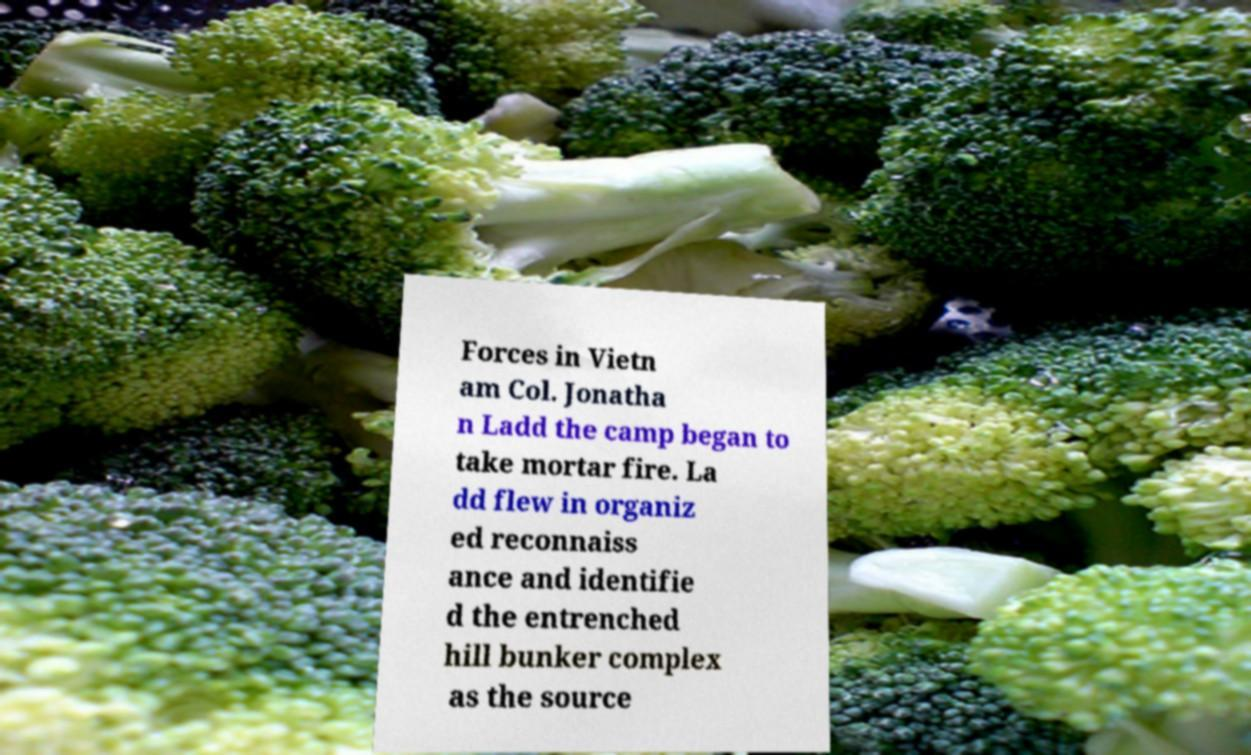Could you assist in decoding the text presented in this image and type it out clearly? Forces in Vietn am Col. Jonatha n Ladd the camp began to take mortar fire. La dd flew in organiz ed reconnaiss ance and identifie d the entrenched hill bunker complex as the source 